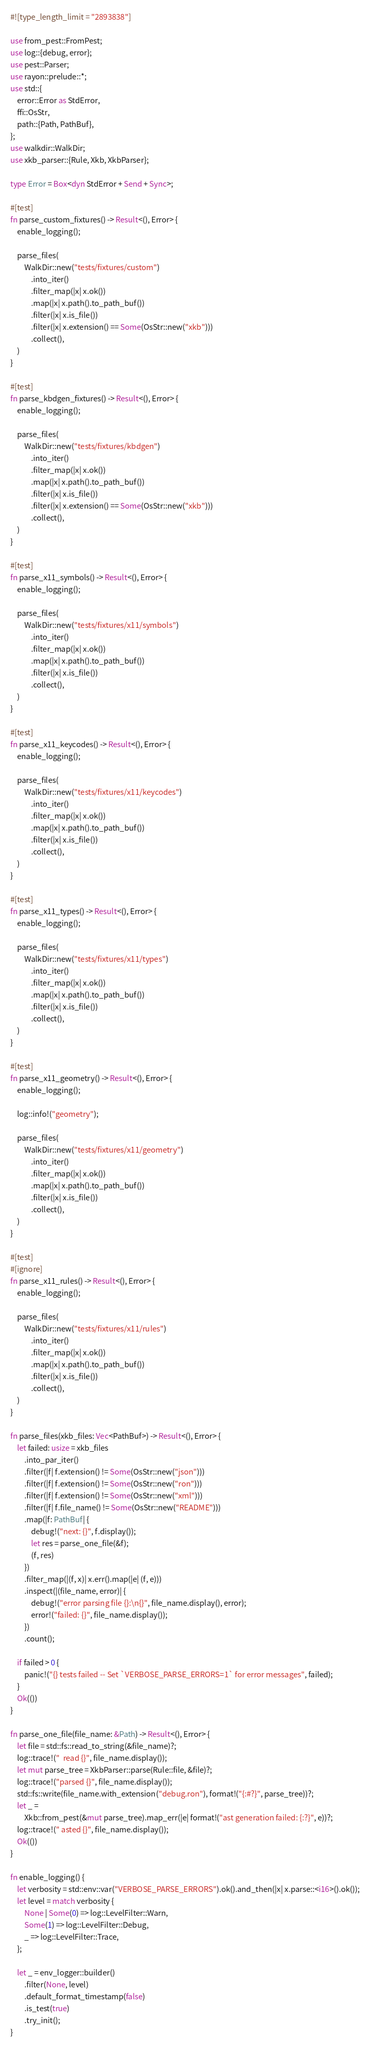Convert code to text. <code><loc_0><loc_0><loc_500><loc_500><_Rust_>#![type_length_limit = "2893838"]

use from_pest::FromPest;
use log::{debug, error};
use pest::Parser;
use rayon::prelude::*;
use std::{
    error::Error as StdError,
    ffi::OsStr,
    path::{Path, PathBuf},
};
use walkdir::WalkDir;
use xkb_parser::{Rule, Xkb, XkbParser};

type Error = Box<dyn StdError + Send + Sync>;

#[test]
fn parse_custom_fixtures() -> Result<(), Error> {
    enable_logging();

    parse_files(
        WalkDir::new("tests/fixtures/custom")
            .into_iter()
            .filter_map(|x| x.ok())
            .map(|x| x.path().to_path_buf())
            .filter(|x| x.is_file())
            .filter(|x| x.extension() == Some(OsStr::new("xkb")))
            .collect(),
    )
}

#[test]
fn parse_kbdgen_fixtures() -> Result<(), Error> {
    enable_logging();

    parse_files(
        WalkDir::new("tests/fixtures/kbdgen")
            .into_iter()
            .filter_map(|x| x.ok())
            .map(|x| x.path().to_path_buf())
            .filter(|x| x.is_file())
            .filter(|x| x.extension() == Some(OsStr::new("xkb")))
            .collect(),
    )
}

#[test]
fn parse_x11_symbols() -> Result<(), Error> {
    enable_logging();

    parse_files(
        WalkDir::new("tests/fixtures/x11/symbols")
            .into_iter()
            .filter_map(|x| x.ok())
            .map(|x| x.path().to_path_buf())
            .filter(|x| x.is_file())
            .collect(),
    )
}

#[test]
fn parse_x11_keycodes() -> Result<(), Error> {
    enable_logging();

    parse_files(
        WalkDir::new("tests/fixtures/x11/keycodes")
            .into_iter()
            .filter_map(|x| x.ok())
            .map(|x| x.path().to_path_buf())
            .filter(|x| x.is_file())
            .collect(),
    )
}

#[test]
fn parse_x11_types() -> Result<(), Error> {
    enable_logging();

    parse_files(
        WalkDir::new("tests/fixtures/x11/types")
            .into_iter()
            .filter_map(|x| x.ok())
            .map(|x| x.path().to_path_buf())
            .filter(|x| x.is_file())
            .collect(),
    )
}

#[test]
fn parse_x11_geometry() -> Result<(), Error> {
    enable_logging();

    log::info!("geometry");

    parse_files(
        WalkDir::new("tests/fixtures/x11/geometry")
            .into_iter()
            .filter_map(|x| x.ok())
            .map(|x| x.path().to_path_buf())
            .filter(|x| x.is_file())
            .collect(),
    )
}

#[test]
#[ignore]
fn parse_x11_rules() -> Result<(), Error> {
    enable_logging();

    parse_files(
        WalkDir::new("tests/fixtures/x11/rules")
            .into_iter()
            .filter_map(|x| x.ok())
            .map(|x| x.path().to_path_buf())
            .filter(|x| x.is_file())
            .collect(),
    )
}

fn parse_files(xkb_files: Vec<PathBuf>) -> Result<(), Error> {
    let failed: usize = xkb_files
        .into_par_iter()
        .filter(|f| f.extension() != Some(OsStr::new("json")))
        .filter(|f| f.extension() != Some(OsStr::new("ron")))
        .filter(|f| f.extension() != Some(OsStr::new("xml")))
        .filter(|f| f.file_name() != Some(OsStr::new("README")))
        .map(|f: PathBuf| {
            debug!("next: {}", f.display());
            let res = parse_one_file(&f);
            (f, res)
        })
        .filter_map(|(f, x)| x.err().map(|e| (f, e)))
        .inspect(|(file_name, error)| {
            debug!("error parsing file {}:\n{}", file_name.display(), error);
            error!("failed: {}", file_name.display());
        })
        .count();

    if failed > 0 {
        panic!("{} tests failed -- Set `VERBOSE_PARSE_ERRORS=1` for error messages", failed);
    }
    Ok(())
}

fn parse_one_file(file_name: &Path) -> Result<(), Error> {
    let file = std::fs::read_to_string(&file_name)?;
    log::trace!("  read {}", file_name.display());
    let mut parse_tree = XkbParser::parse(Rule::file, &file)?;
    log::trace!("parsed {}", file_name.display());
    std::fs::write(file_name.with_extension("debug.ron"), format!("{:#?}", parse_tree))?;
    let _ =
        Xkb::from_pest(&mut parse_tree).map_err(|e| format!("ast generation failed: {:?}", e))?;
    log::trace!(" asted {}", file_name.display());
    Ok(())
}

fn enable_logging() {
    let verbosity = std::env::var("VERBOSE_PARSE_ERRORS").ok().and_then(|x| x.parse::<i16>().ok());
    let level = match verbosity {
        None | Some(0) => log::LevelFilter::Warn,
        Some(1) => log::LevelFilter::Debug,
        _ => log::LevelFilter::Trace,
    };

    let _ = env_logger::builder()
        .filter(None, level)
        .default_format_timestamp(false)
        .is_test(true)
        .try_init();
}
</code> 